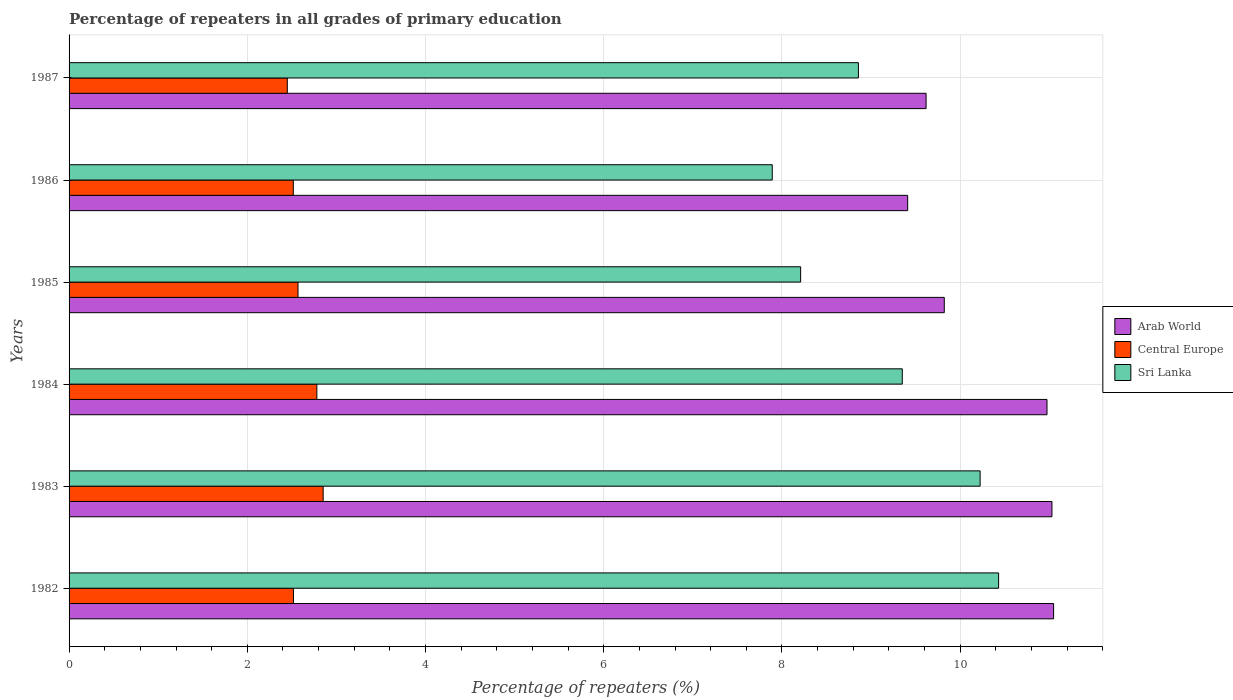How many bars are there on the 4th tick from the bottom?
Your answer should be compact. 3. What is the label of the 5th group of bars from the top?
Ensure brevity in your answer.  1983. In how many cases, is the number of bars for a given year not equal to the number of legend labels?
Ensure brevity in your answer.  0. What is the percentage of repeaters in Sri Lanka in 1985?
Provide a succinct answer. 8.21. Across all years, what is the maximum percentage of repeaters in Sri Lanka?
Offer a terse response. 10.43. Across all years, what is the minimum percentage of repeaters in Arab World?
Give a very brief answer. 9.41. What is the total percentage of repeaters in Arab World in the graph?
Offer a terse response. 61.9. What is the difference between the percentage of repeaters in Arab World in 1982 and that in 1983?
Your response must be concise. 0.02. What is the difference between the percentage of repeaters in Sri Lanka in 1983 and the percentage of repeaters in Arab World in 1984?
Your answer should be very brief. -0.75. What is the average percentage of repeaters in Arab World per year?
Offer a terse response. 10.32. In the year 1985, what is the difference between the percentage of repeaters in Sri Lanka and percentage of repeaters in Central Europe?
Offer a terse response. 5.64. In how many years, is the percentage of repeaters in Sri Lanka greater than 4.4 %?
Offer a terse response. 6. What is the ratio of the percentage of repeaters in Arab World in 1982 to that in 1987?
Give a very brief answer. 1.15. What is the difference between the highest and the second highest percentage of repeaters in Sri Lanka?
Your response must be concise. 0.21. What is the difference between the highest and the lowest percentage of repeaters in Sri Lanka?
Your response must be concise. 2.54. Is the sum of the percentage of repeaters in Arab World in 1984 and 1986 greater than the maximum percentage of repeaters in Sri Lanka across all years?
Give a very brief answer. Yes. What does the 2nd bar from the top in 1983 represents?
Your answer should be very brief. Central Europe. What does the 3rd bar from the bottom in 1984 represents?
Give a very brief answer. Sri Lanka. Is it the case that in every year, the sum of the percentage of repeaters in Arab World and percentage of repeaters in Sri Lanka is greater than the percentage of repeaters in Central Europe?
Make the answer very short. Yes. How many bars are there?
Offer a very short reply. 18. Are all the bars in the graph horizontal?
Provide a short and direct response. Yes. What is the difference between two consecutive major ticks on the X-axis?
Make the answer very short. 2. Are the values on the major ticks of X-axis written in scientific E-notation?
Provide a short and direct response. No. Does the graph contain grids?
Make the answer very short. Yes. Where does the legend appear in the graph?
Ensure brevity in your answer.  Center right. How many legend labels are there?
Provide a short and direct response. 3. How are the legend labels stacked?
Ensure brevity in your answer.  Vertical. What is the title of the graph?
Make the answer very short. Percentage of repeaters in all grades of primary education. What is the label or title of the X-axis?
Your answer should be very brief. Percentage of repeaters (%). What is the label or title of the Y-axis?
Provide a succinct answer. Years. What is the Percentage of repeaters (%) in Arab World in 1982?
Make the answer very short. 11.05. What is the Percentage of repeaters (%) of Central Europe in 1982?
Your response must be concise. 2.52. What is the Percentage of repeaters (%) of Sri Lanka in 1982?
Offer a very short reply. 10.43. What is the Percentage of repeaters (%) of Arab World in 1983?
Your response must be concise. 11.03. What is the Percentage of repeaters (%) of Central Europe in 1983?
Your answer should be compact. 2.85. What is the Percentage of repeaters (%) of Sri Lanka in 1983?
Your answer should be very brief. 10.22. What is the Percentage of repeaters (%) in Arab World in 1984?
Your answer should be compact. 10.97. What is the Percentage of repeaters (%) in Central Europe in 1984?
Give a very brief answer. 2.78. What is the Percentage of repeaters (%) in Sri Lanka in 1984?
Provide a succinct answer. 9.35. What is the Percentage of repeaters (%) in Arab World in 1985?
Provide a short and direct response. 9.82. What is the Percentage of repeaters (%) in Central Europe in 1985?
Ensure brevity in your answer.  2.57. What is the Percentage of repeaters (%) of Sri Lanka in 1985?
Your answer should be very brief. 8.21. What is the Percentage of repeaters (%) in Arab World in 1986?
Ensure brevity in your answer.  9.41. What is the Percentage of repeaters (%) in Central Europe in 1986?
Offer a terse response. 2.52. What is the Percentage of repeaters (%) in Sri Lanka in 1986?
Offer a terse response. 7.89. What is the Percentage of repeaters (%) in Arab World in 1987?
Your answer should be compact. 9.62. What is the Percentage of repeaters (%) in Central Europe in 1987?
Provide a succinct answer. 2.45. What is the Percentage of repeaters (%) of Sri Lanka in 1987?
Provide a short and direct response. 8.86. Across all years, what is the maximum Percentage of repeaters (%) in Arab World?
Keep it short and to the point. 11.05. Across all years, what is the maximum Percentage of repeaters (%) of Central Europe?
Offer a terse response. 2.85. Across all years, what is the maximum Percentage of repeaters (%) of Sri Lanka?
Ensure brevity in your answer.  10.43. Across all years, what is the minimum Percentage of repeaters (%) in Arab World?
Provide a succinct answer. 9.41. Across all years, what is the minimum Percentage of repeaters (%) in Central Europe?
Your response must be concise. 2.45. Across all years, what is the minimum Percentage of repeaters (%) of Sri Lanka?
Provide a short and direct response. 7.89. What is the total Percentage of repeaters (%) in Arab World in the graph?
Give a very brief answer. 61.9. What is the total Percentage of repeaters (%) in Central Europe in the graph?
Provide a short and direct response. 15.68. What is the total Percentage of repeaters (%) in Sri Lanka in the graph?
Offer a very short reply. 54.96. What is the difference between the Percentage of repeaters (%) of Arab World in 1982 and that in 1983?
Provide a succinct answer. 0.02. What is the difference between the Percentage of repeaters (%) in Central Europe in 1982 and that in 1983?
Your answer should be compact. -0.33. What is the difference between the Percentage of repeaters (%) of Sri Lanka in 1982 and that in 1983?
Your response must be concise. 0.21. What is the difference between the Percentage of repeaters (%) of Arab World in 1982 and that in 1984?
Provide a succinct answer. 0.07. What is the difference between the Percentage of repeaters (%) of Central Europe in 1982 and that in 1984?
Offer a very short reply. -0.26. What is the difference between the Percentage of repeaters (%) of Sri Lanka in 1982 and that in 1984?
Give a very brief answer. 1.08. What is the difference between the Percentage of repeaters (%) in Arab World in 1982 and that in 1985?
Keep it short and to the point. 1.23. What is the difference between the Percentage of repeaters (%) in Central Europe in 1982 and that in 1985?
Your answer should be very brief. -0.05. What is the difference between the Percentage of repeaters (%) of Sri Lanka in 1982 and that in 1985?
Offer a very short reply. 2.22. What is the difference between the Percentage of repeaters (%) of Arab World in 1982 and that in 1986?
Make the answer very short. 1.64. What is the difference between the Percentage of repeaters (%) of Central Europe in 1982 and that in 1986?
Your answer should be compact. 0. What is the difference between the Percentage of repeaters (%) in Sri Lanka in 1982 and that in 1986?
Provide a succinct answer. 2.54. What is the difference between the Percentage of repeaters (%) in Arab World in 1982 and that in 1987?
Provide a succinct answer. 1.43. What is the difference between the Percentage of repeaters (%) in Central Europe in 1982 and that in 1987?
Your answer should be very brief. 0.07. What is the difference between the Percentage of repeaters (%) of Sri Lanka in 1982 and that in 1987?
Provide a succinct answer. 1.57. What is the difference between the Percentage of repeaters (%) of Arab World in 1983 and that in 1984?
Offer a very short reply. 0.06. What is the difference between the Percentage of repeaters (%) of Central Europe in 1983 and that in 1984?
Give a very brief answer. 0.07. What is the difference between the Percentage of repeaters (%) of Sri Lanka in 1983 and that in 1984?
Offer a very short reply. 0.87. What is the difference between the Percentage of repeaters (%) of Arab World in 1983 and that in 1985?
Your answer should be compact. 1.21. What is the difference between the Percentage of repeaters (%) in Central Europe in 1983 and that in 1985?
Provide a short and direct response. 0.28. What is the difference between the Percentage of repeaters (%) of Sri Lanka in 1983 and that in 1985?
Provide a short and direct response. 2.01. What is the difference between the Percentage of repeaters (%) of Arab World in 1983 and that in 1986?
Provide a succinct answer. 1.62. What is the difference between the Percentage of repeaters (%) in Central Europe in 1983 and that in 1986?
Ensure brevity in your answer.  0.34. What is the difference between the Percentage of repeaters (%) of Sri Lanka in 1983 and that in 1986?
Provide a succinct answer. 2.33. What is the difference between the Percentage of repeaters (%) of Arab World in 1983 and that in 1987?
Your answer should be compact. 1.41. What is the difference between the Percentage of repeaters (%) of Central Europe in 1983 and that in 1987?
Provide a short and direct response. 0.4. What is the difference between the Percentage of repeaters (%) of Sri Lanka in 1983 and that in 1987?
Your response must be concise. 1.37. What is the difference between the Percentage of repeaters (%) of Arab World in 1984 and that in 1985?
Provide a succinct answer. 1.15. What is the difference between the Percentage of repeaters (%) in Central Europe in 1984 and that in 1985?
Provide a succinct answer. 0.21. What is the difference between the Percentage of repeaters (%) of Sri Lanka in 1984 and that in 1985?
Your response must be concise. 1.14. What is the difference between the Percentage of repeaters (%) of Arab World in 1984 and that in 1986?
Offer a terse response. 1.56. What is the difference between the Percentage of repeaters (%) of Central Europe in 1984 and that in 1986?
Keep it short and to the point. 0.26. What is the difference between the Percentage of repeaters (%) of Sri Lanka in 1984 and that in 1986?
Give a very brief answer. 1.46. What is the difference between the Percentage of repeaters (%) of Arab World in 1984 and that in 1987?
Provide a short and direct response. 1.36. What is the difference between the Percentage of repeaters (%) of Central Europe in 1984 and that in 1987?
Your answer should be very brief. 0.33. What is the difference between the Percentage of repeaters (%) in Sri Lanka in 1984 and that in 1987?
Give a very brief answer. 0.49. What is the difference between the Percentage of repeaters (%) of Arab World in 1985 and that in 1986?
Provide a short and direct response. 0.41. What is the difference between the Percentage of repeaters (%) of Central Europe in 1985 and that in 1986?
Offer a very short reply. 0.05. What is the difference between the Percentage of repeaters (%) of Sri Lanka in 1985 and that in 1986?
Keep it short and to the point. 0.32. What is the difference between the Percentage of repeaters (%) of Arab World in 1985 and that in 1987?
Your answer should be very brief. 0.2. What is the difference between the Percentage of repeaters (%) in Central Europe in 1985 and that in 1987?
Provide a short and direct response. 0.12. What is the difference between the Percentage of repeaters (%) of Sri Lanka in 1985 and that in 1987?
Your answer should be compact. -0.65. What is the difference between the Percentage of repeaters (%) of Arab World in 1986 and that in 1987?
Offer a terse response. -0.21. What is the difference between the Percentage of repeaters (%) of Central Europe in 1986 and that in 1987?
Keep it short and to the point. 0.07. What is the difference between the Percentage of repeaters (%) in Sri Lanka in 1986 and that in 1987?
Keep it short and to the point. -0.97. What is the difference between the Percentage of repeaters (%) in Arab World in 1982 and the Percentage of repeaters (%) in Central Europe in 1983?
Provide a succinct answer. 8.2. What is the difference between the Percentage of repeaters (%) in Arab World in 1982 and the Percentage of repeaters (%) in Sri Lanka in 1983?
Your answer should be very brief. 0.82. What is the difference between the Percentage of repeaters (%) of Central Europe in 1982 and the Percentage of repeaters (%) of Sri Lanka in 1983?
Make the answer very short. -7.71. What is the difference between the Percentage of repeaters (%) in Arab World in 1982 and the Percentage of repeaters (%) in Central Europe in 1984?
Provide a succinct answer. 8.27. What is the difference between the Percentage of repeaters (%) in Arab World in 1982 and the Percentage of repeaters (%) in Sri Lanka in 1984?
Provide a short and direct response. 1.7. What is the difference between the Percentage of repeaters (%) of Central Europe in 1982 and the Percentage of repeaters (%) of Sri Lanka in 1984?
Provide a succinct answer. -6.83. What is the difference between the Percentage of repeaters (%) in Arab World in 1982 and the Percentage of repeaters (%) in Central Europe in 1985?
Your answer should be very brief. 8.48. What is the difference between the Percentage of repeaters (%) in Arab World in 1982 and the Percentage of repeaters (%) in Sri Lanka in 1985?
Offer a very short reply. 2.84. What is the difference between the Percentage of repeaters (%) of Central Europe in 1982 and the Percentage of repeaters (%) of Sri Lanka in 1985?
Provide a succinct answer. -5.69. What is the difference between the Percentage of repeaters (%) in Arab World in 1982 and the Percentage of repeaters (%) in Central Europe in 1986?
Your answer should be compact. 8.53. What is the difference between the Percentage of repeaters (%) in Arab World in 1982 and the Percentage of repeaters (%) in Sri Lanka in 1986?
Make the answer very short. 3.16. What is the difference between the Percentage of repeaters (%) of Central Europe in 1982 and the Percentage of repeaters (%) of Sri Lanka in 1986?
Your response must be concise. -5.37. What is the difference between the Percentage of repeaters (%) in Arab World in 1982 and the Percentage of repeaters (%) in Central Europe in 1987?
Keep it short and to the point. 8.6. What is the difference between the Percentage of repeaters (%) in Arab World in 1982 and the Percentage of repeaters (%) in Sri Lanka in 1987?
Provide a short and direct response. 2.19. What is the difference between the Percentage of repeaters (%) in Central Europe in 1982 and the Percentage of repeaters (%) in Sri Lanka in 1987?
Keep it short and to the point. -6.34. What is the difference between the Percentage of repeaters (%) in Arab World in 1983 and the Percentage of repeaters (%) in Central Europe in 1984?
Your response must be concise. 8.25. What is the difference between the Percentage of repeaters (%) of Arab World in 1983 and the Percentage of repeaters (%) of Sri Lanka in 1984?
Ensure brevity in your answer.  1.68. What is the difference between the Percentage of repeaters (%) of Central Europe in 1983 and the Percentage of repeaters (%) of Sri Lanka in 1984?
Provide a short and direct response. -6.5. What is the difference between the Percentage of repeaters (%) in Arab World in 1983 and the Percentage of repeaters (%) in Central Europe in 1985?
Ensure brevity in your answer.  8.46. What is the difference between the Percentage of repeaters (%) of Arab World in 1983 and the Percentage of repeaters (%) of Sri Lanka in 1985?
Your response must be concise. 2.82. What is the difference between the Percentage of repeaters (%) in Central Europe in 1983 and the Percentage of repeaters (%) in Sri Lanka in 1985?
Your response must be concise. -5.36. What is the difference between the Percentage of repeaters (%) of Arab World in 1983 and the Percentage of repeaters (%) of Central Europe in 1986?
Provide a succinct answer. 8.51. What is the difference between the Percentage of repeaters (%) in Arab World in 1983 and the Percentage of repeaters (%) in Sri Lanka in 1986?
Your response must be concise. 3.14. What is the difference between the Percentage of repeaters (%) of Central Europe in 1983 and the Percentage of repeaters (%) of Sri Lanka in 1986?
Offer a very short reply. -5.04. What is the difference between the Percentage of repeaters (%) in Arab World in 1983 and the Percentage of repeaters (%) in Central Europe in 1987?
Provide a short and direct response. 8.58. What is the difference between the Percentage of repeaters (%) of Arab World in 1983 and the Percentage of repeaters (%) of Sri Lanka in 1987?
Provide a succinct answer. 2.17. What is the difference between the Percentage of repeaters (%) of Central Europe in 1983 and the Percentage of repeaters (%) of Sri Lanka in 1987?
Keep it short and to the point. -6.01. What is the difference between the Percentage of repeaters (%) of Arab World in 1984 and the Percentage of repeaters (%) of Central Europe in 1985?
Your response must be concise. 8.41. What is the difference between the Percentage of repeaters (%) of Arab World in 1984 and the Percentage of repeaters (%) of Sri Lanka in 1985?
Ensure brevity in your answer.  2.76. What is the difference between the Percentage of repeaters (%) of Central Europe in 1984 and the Percentage of repeaters (%) of Sri Lanka in 1985?
Make the answer very short. -5.43. What is the difference between the Percentage of repeaters (%) of Arab World in 1984 and the Percentage of repeaters (%) of Central Europe in 1986?
Your response must be concise. 8.46. What is the difference between the Percentage of repeaters (%) of Arab World in 1984 and the Percentage of repeaters (%) of Sri Lanka in 1986?
Give a very brief answer. 3.08. What is the difference between the Percentage of repeaters (%) in Central Europe in 1984 and the Percentage of repeaters (%) in Sri Lanka in 1986?
Offer a terse response. -5.11. What is the difference between the Percentage of repeaters (%) of Arab World in 1984 and the Percentage of repeaters (%) of Central Europe in 1987?
Your answer should be very brief. 8.53. What is the difference between the Percentage of repeaters (%) of Arab World in 1984 and the Percentage of repeaters (%) of Sri Lanka in 1987?
Your answer should be very brief. 2.12. What is the difference between the Percentage of repeaters (%) in Central Europe in 1984 and the Percentage of repeaters (%) in Sri Lanka in 1987?
Give a very brief answer. -6.08. What is the difference between the Percentage of repeaters (%) of Arab World in 1985 and the Percentage of repeaters (%) of Central Europe in 1986?
Keep it short and to the point. 7.31. What is the difference between the Percentage of repeaters (%) of Arab World in 1985 and the Percentage of repeaters (%) of Sri Lanka in 1986?
Give a very brief answer. 1.93. What is the difference between the Percentage of repeaters (%) of Central Europe in 1985 and the Percentage of repeaters (%) of Sri Lanka in 1986?
Offer a terse response. -5.32. What is the difference between the Percentage of repeaters (%) in Arab World in 1985 and the Percentage of repeaters (%) in Central Europe in 1987?
Ensure brevity in your answer.  7.37. What is the difference between the Percentage of repeaters (%) of Arab World in 1985 and the Percentage of repeaters (%) of Sri Lanka in 1987?
Offer a very short reply. 0.96. What is the difference between the Percentage of repeaters (%) of Central Europe in 1985 and the Percentage of repeaters (%) of Sri Lanka in 1987?
Ensure brevity in your answer.  -6.29. What is the difference between the Percentage of repeaters (%) in Arab World in 1986 and the Percentage of repeaters (%) in Central Europe in 1987?
Your answer should be very brief. 6.96. What is the difference between the Percentage of repeaters (%) of Arab World in 1986 and the Percentage of repeaters (%) of Sri Lanka in 1987?
Keep it short and to the point. 0.55. What is the difference between the Percentage of repeaters (%) of Central Europe in 1986 and the Percentage of repeaters (%) of Sri Lanka in 1987?
Provide a succinct answer. -6.34. What is the average Percentage of repeaters (%) in Arab World per year?
Your response must be concise. 10.32. What is the average Percentage of repeaters (%) in Central Europe per year?
Provide a succinct answer. 2.61. What is the average Percentage of repeaters (%) of Sri Lanka per year?
Give a very brief answer. 9.16. In the year 1982, what is the difference between the Percentage of repeaters (%) in Arab World and Percentage of repeaters (%) in Central Europe?
Offer a terse response. 8.53. In the year 1982, what is the difference between the Percentage of repeaters (%) of Arab World and Percentage of repeaters (%) of Sri Lanka?
Ensure brevity in your answer.  0.62. In the year 1982, what is the difference between the Percentage of repeaters (%) in Central Europe and Percentage of repeaters (%) in Sri Lanka?
Offer a terse response. -7.91. In the year 1983, what is the difference between the Percentage of repeaters (%) of Arab World and Percentage of repeaters (%) of Central Europe?
Offer a very short reply. 8.18. In the year 1983, what is the difference between the Percentage of repeaters (%) in Arab World and Percentage of repeaters (%) in Sri Lanka?
Your answer should be very brief. 0.81. In the year 1983, what is the difference between the Percentage of repeaters (%) of Central Europe and Percentage of repeaters (%) of Sri Lanka?
Ensure brevity in your answer.  -7.37. In the year 1984, what is the difference between the Percentage of repeaters (%) in Arab World and Percentage of repeaters (%) in Central Europe?
Your answer should be compact. 8.19. In the year 1984, what is the difference between the Percentage of repeaters (%) in Arab World and Percentage of repeaters (%) in Sri Lanka?
Your answer should be compact. 1.62. In the year 1984, what is the difference between the Percentage of repeaters (%) in Central Europe and Percentage of repeaters (%) in Sri Lanka?
Offer a terse response. -6.57. In the year 1985, what is the difference between the Percentage of repeaters (%) of Arab World and Percentage of repeaters (%) of Central Europe?
Keep it short and to the point. 7.25. In the year 1985, what is the difference between the Percentage of repeaters (%) in Arab World and Percentage of repeaters (%) in Sri Lanka?
Make the answer very short. 1.61. In the year 1985, what is the difference between the Percentage of repeaters (%) of Central Europe and Percentage of repeaters (%) of Sri Lanka?
Offer a terse response. -5.64. In the year 1986, what is the difference between the Percentage of repeaters (%) of Arab World and Percentage of repeaters (%) of Central Europe?
Provide a short and direct response. 6.89. In the year 1986, what is the difference between the Percentage of repeaters (%) in Arab World and Percentage of repeaters (%) in Sri Lanka?
Provide a succinct answer. 1.52. In the year 1986, what is the difference between the Percentage of repeaters (%) of Central Europe and Percentage of repeaters (%) of Sri Lanka?
Keep it short and to the point. -5.37. In the year 1987, what is the difference between the Percentage of repeaters (%) in Arab World and Percentage of repeaters (%) in Central Europe?
Provide a short and direct response. 7.17. In the year 1987, what is the difference between the Percentage of repeaters (%) in Arab World and Percentage of repeaters (%) in Sri Lanka?
Ensure brevity in your answer.  0.76. In the year 1987, what is the difference between the Percentage of repeaters (%) in Central Europe and Percentage of repeaters (%) in Sri Lanka?
Your response must be concise. -6.41. What is the ratio of the Percentage of repeaters (%) of Central Europe in 1982 to that in 1983?
Make the answer very short. 0.88. What is the ratio of the Percentage of repeaters (%) in Sri Lanka in 1982 to that in 1983?
Your response must be concise. 1.02. What is the ratio of the Percentage of repeaters (%) in Central Europe in 1982 to that in 1984?
Provide a succinct answer. 0.91. What is the ratio of the Percentage of repeaters (%) in Sri Lanka in 1982 to that in 1984?
Your answer should be very brief. 1.12. What is the ratio of the Percentage of repeaters (%) in Arab World in 1982 to that in 1985?
Your answer should be very brief. 1.12. What is the ratio of the Percentage of repeaters (%) of Central Europe in 1982 to that in 1985?
Your answer should be very brief. 0.98. What is the ratio of the Percentage of repeaters (%) of Sri Lanka in 1982 to that in 1985?
Ensure brevity in your answer.  1.27. What is the ratio of the Percentage of repeaters (%) in Arab World in 1982 to that in 1986?
Your answer should be very brief. 1.17. What is the ratio of the Percentage of repeaters (%) in Central Europe in 1982 to that in 1986?
Provide a succinct answer. 1. What is the ratio of the Percentage of repeaters (%) in Sri Lanka in 1982 to that in 1986?
Provide a short and direct response. 1.32. What is the ratio of the Percentage of repeaters (%) in Arab World in 1982 to that in 1987?
Your answer should be very brief. 1.15. What is the ratio of the Percentage of repeaters (%) of Central Europe in 1982 to that in 1987?
Keep it short and to the point. 1.03. What is the ratio of the Percentage of repeaters (%) in Sri Lanka in 1982 to that in 1987?
Your answer should be very brief. 1.18. What is the ratio of the Percentage of repeaters (%) in Central Europe in 1983 to that in 1984?
Provide a short and direct response. 1.03. What is the ratio of the Percentage of repeaters (%) in Sri Lanka in 1983 to that in 1984?
Make the answer very short. 1.09. What is the ratio of the Percentage of repeaters (%) of Arab World in 1983 to that in 1985?
Ensure brevity in your answer.  1.12. What is the ratio of the Percentage of repeaters (%) of Central Europe in 1983 to that in 1985?
Your answer should be very brief. 1.11. What is the ratio of the Percentage of repeaters (%) of Sri Lanka in 1983 to that in 1985?
Offer a very short reply. 1.25. What is the ratio of the Percentage of repeaters (%) of Arab World in 1983 to that in 1986?
Your answer should be very brief. 1.17. What is the ratio of the Percentage of repeaters (%) of Central Europe in 1983 to that in 1986?
Your answer should be very brief. 1.13. What is the ratio of the Percentage of repeaters (%) in Sri Lanka in 1983 to that in 1986?
Give a very brief answer. 1.3. What is the ratio of the Percentage of repeaters (%) in Arab World in 1983 to that in 1987?
Offer a very short reply. 1.15. What is the ratio of the Percentage of repeaters (%) of Central Europe in 1983 to that in 1987?
Provide a succinct answer. 1.16. What is the ratio of the Percentage of repeaters (%) of Sri Lanka in 1983 to that in 1987?
Your response must be concise. 1.15. What is the ratio of the Percentage of repeaters (%) in Arab World in 1984 to that in 1985?
Your answer should be very brief. 1.12. What is the ratio of the Percentage of repeaters (%) of Central Europe in 1984 to that in 1985?
Offer a very short reply. 1.08. What is the ratio of the Percentage of repeaters (%) in Sri Lanka in 1984 to that in 1985?
Ensure brevity in your answer.  1.14. What is the ratio of the Percentage of repeaters (%) of Arab World in 1984 to that in 1986?
Offer a terse response. 1.17. What is the ratio of the Percentage of repeaters (%) of Central Europe in 1984 to that in 1986?
Offer a very short reply. 1.11. What is the ratio of the Percentage of repeaters (%) in Sri Lanka in 1984 to that in 1986?
Offer a terse response. 1.18. What is the ratio of the Percentage of repeaters (%) in Arab World in 1984 to that in 1987?
Your answer should be very brief. 1.14. What is the ratio of the Percentage of repeaters (%) of Central Europe in 1984 to that in 1987?
Your answer should be compact. 1.14. What is the ratio of the Percentage of repeaters (%) of Sri Lanka in 1984 to that in 1987?
Offer a terse response. 1.06. What is the ratio of the Percentage of repeaters (%) in Arab World in 1985 to that in 1986?
Make the answer very short. 1.04. What is the ratio of the Percentage of repeaters (%) in Sri Lanka in 1985 to that in 1986?
Your answer should be compact. 1.04. What is the ratio of the Percentage of repeaters (%) in Arab World in 1985 to that in 1987?
Provide a short and direct response. 1.02. What is the ratio of the Percentage of repeaters (%) of Central Europe in 1985 to that in 1987?
Provide a succinct answer. 1.05. What is the ratio of the Percentage of repeaters (%) in Sri Lanka in 1985 to that in 1987?
Give a very brief answer. 0.93. What is the ratio of the Percentage of repeaters (%) of Arab World in 1986 to that in 1987?
Ensure brevity in your answer.  0.98. What is the ratio of the Percentage of repeaters (%) of Central Europe in 1986 to that in 1987?
Ensure brevity in your answer.  1.03. What is the ratio of the Percentage of repeaters (%) of Sri Lanka in 1986 to that in 1987?
Your answer should be compact. 0.89. What is the difference between the highest and the second highest Percentage of repeaters (%) of Arab World?
Your answer should be very brief. 0.02. What is the difference between the highest and the second highest Percentage of repeaters (%) of Central Europe?
Provide a succinct answer. 0.07. What is the difference between the highest and the second highest Percentage of repeaters (%) in Sri Lanka?
Ensure brevity in your answer.  0.21. What is the difference between the highest and the lowest Percentage of repeaters (%) of Arab World?
Offer a terse response. 1.64. What is the difference between the highest and the lowest Percentage of repeaters (%) of Central Europe?
Offer a terse response. 0.4. What is the difference between the highest and the lowest Percentage of repeaters (%) of Sri Lanka?
Make the answer very short. 2.54. 